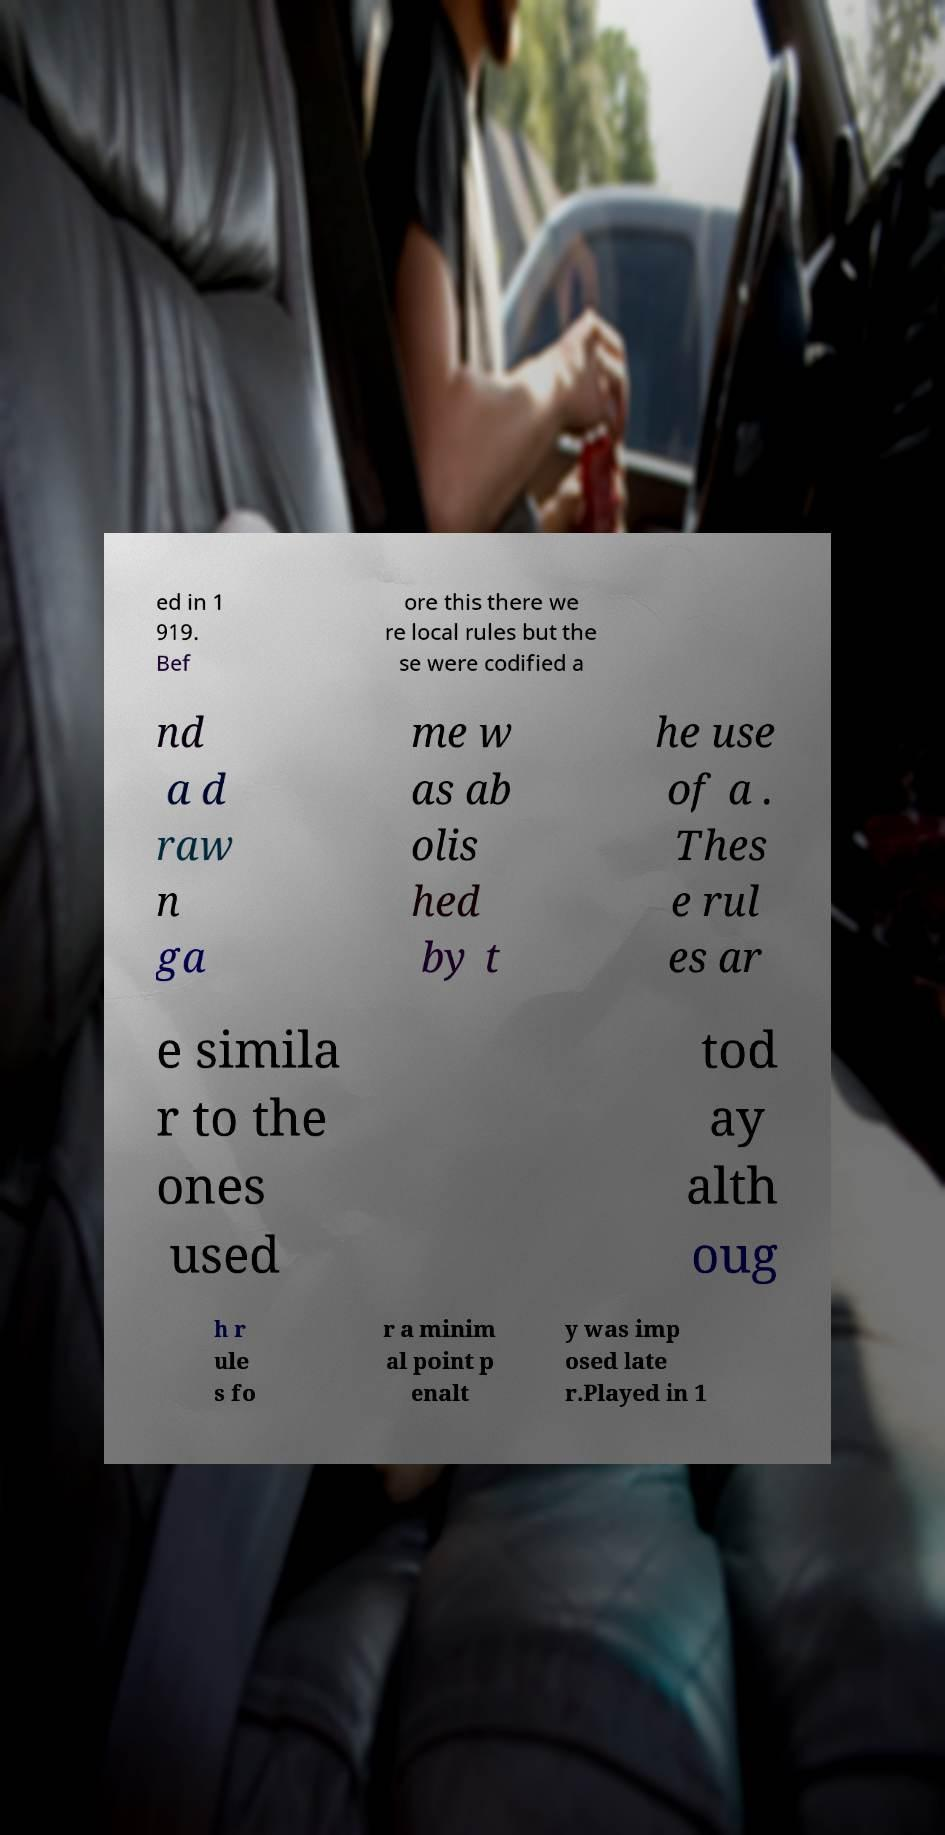Could you assist in decoding the text presented in this image and type it out clearly? ed in 1 919. Bef ore this there we re local rules but the se were codified a nd a d raw n ga me w as ab olis hed by t he use of a . Thes e rul es ar e simila r to the ones used tod ay alth oug h r ule s fo r a minim al point p enalt y was imp osed late r.Played in 1 